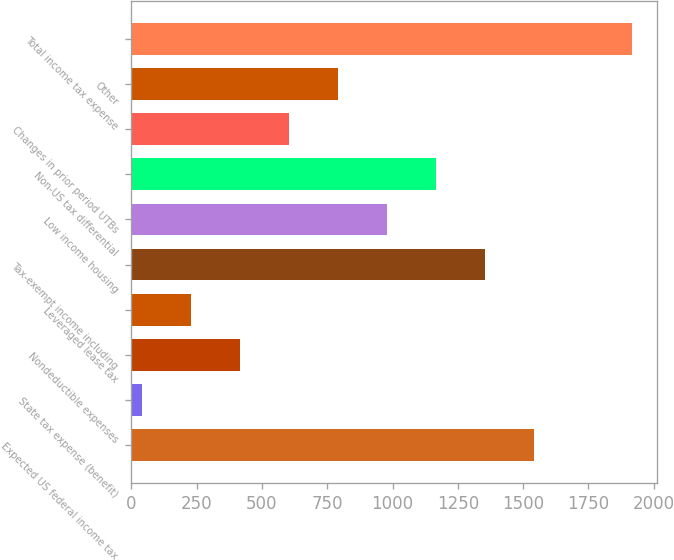<chart> <loc_0><loc_0><loc_500><loc_500><bar_chart><fcel>Expected US federal income tax<fcel>State tax expense (benefit)<fcel>Nondeductible expenses<fcel>Leveraged lease tax<fcel>Tax-exempt income including<fcel>Low income housing<fcel>Non-US tax differential<fcel>Changes in prior period UTBs<fcel>Other<fcel>Total income tax expense<nl><fcel>1541.2<fcel>42<fcel>416.8<fcel>229.4<fcel>1353.8<fcel>979<fcel>1166.4<fcel>604.2<fcel>791.6<fcel>1916<nl></chart> 